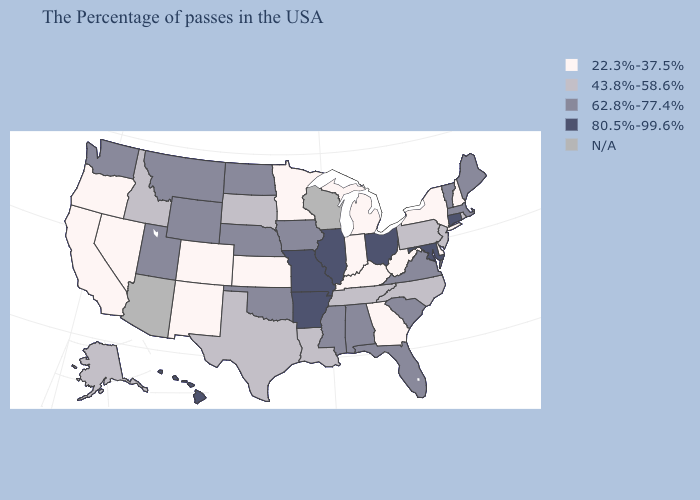Does South Carolina have the lowest value in the USA?
Be succinct. No. What is the lowest value in the USA?
Be succinct. 22.3%-37.5%. What is the lowest value in the USA?
Concise answer only. 22.3%-37.5%. How many symbols are there in the legend?
Write a very short answer. 5. Name the states that have a value in the range N/A?
Give a very brief answer. Wisconsin, Arizona. Name the states that have a value in the range 43.8%-58.6%?
Concise answer only. Rhode Island, New Jersey, Pennsylvania, North Carolina, Tennessee, Louisiana, Texas, South Dakota, Idaho, Alaska. What is the lowest value in the USA?
Be succinct. 22.3%-37.5%. What is the value of Mississippi?
Answer briefly. 62.8%-77.4%. What is the value of Maryland?
Give a very brief answer. 80.5%-99.6%. Name the states that have a value in the range N/A?
Be succinct. Wisconsin, Arizona. Name the states that have a value in the range 43.8%-58.6%?
Short answer required. Rhode Island, New Jersey, Pennsylvania, North Carolina, Tennessee, Louisiana, Texas, South Dakota, Idaho, Alaska. Name the states that have a value in the range 22.3%-37.5%?
Concise answer only. New Hampshire, New York, Delaware, West Virginia, Georgia, Michigan, Kentucky, Indiana, Minnesota, Kansas, Colorado, New Mexico, Nevada, California, Oregon. Among the states that border New Jersey , which have the highest value?
Short answer required. Pennsylvania. 